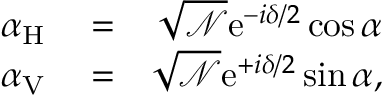Convert formula to latex. <formula><loc_0><loc_0><loc_500><loc_500>\begin{array} { r l r } { \alpha _ { H } } & = } & { \sqrt { \mathcal { N } } e ^ { - i \delta / 2 } \cos \alpha } \\ { \alpha _ { V } } & = } & { \sqrt { \mathcal { N } } e ^ { + i \delta / 2 } \sin \alpha , } \end{array}</formula> 